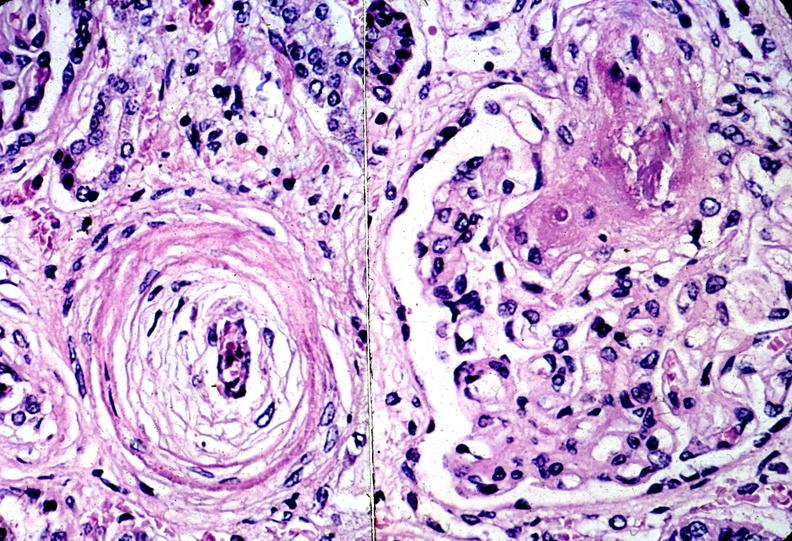what does this image show?
Answer the question using a single word or phrase. Kidney 